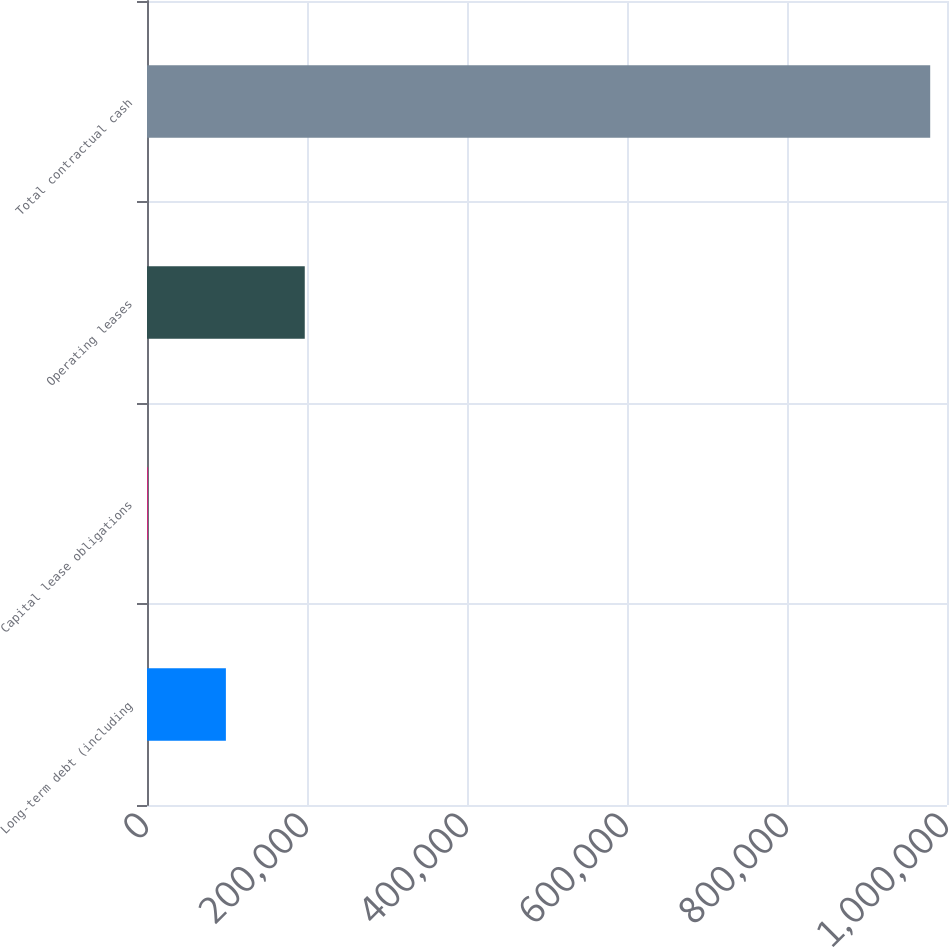Convert chart to OTSL. <chart><loc_0><loc_0><loc_500><loc_500><bar_chart><fcel>Long-term debt (including<fcel>Capital lease obligations<fcel>Operating leases<fcel>Total contractual cash<nl><fcel>98611.7<fcel>790<fcel>197199<fcel>979007<nl></chart> 